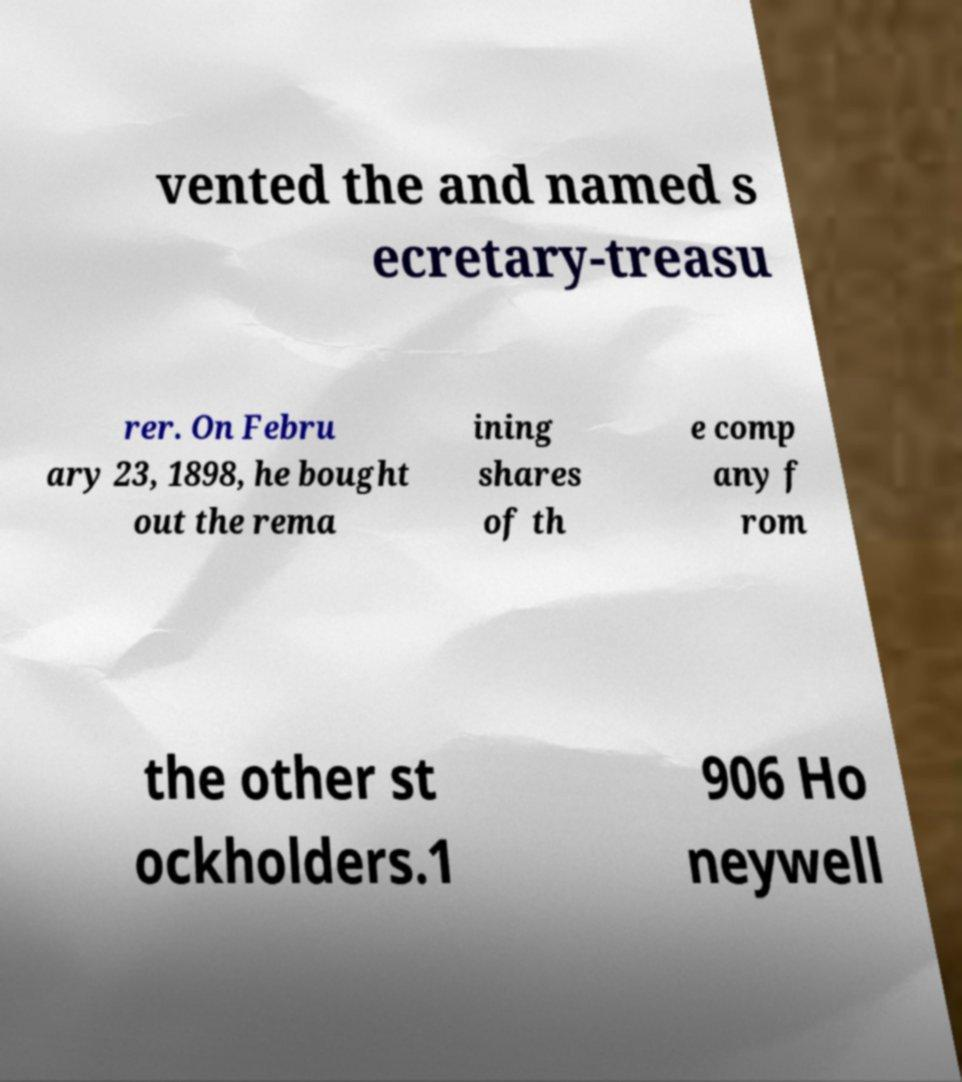Could you extract and type out the text from this image? vented the and named s ecretary-treasu rer. On Febru ary 23, 1898, he bought out the rema ining shares of th e comp any f rom the other st ockholders.1 906 Ho neywell 